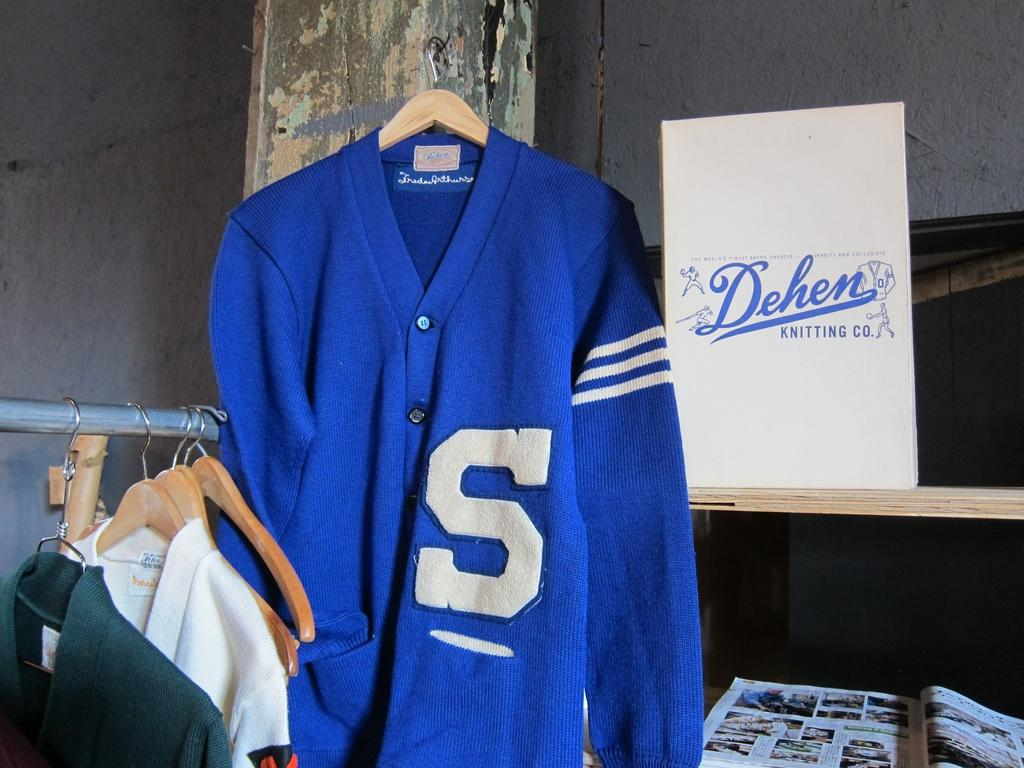<image>
Give a short and clear explanation of the subsequent image. A Dehen blue sweater in some kind of stuff hanging up on the wall. 